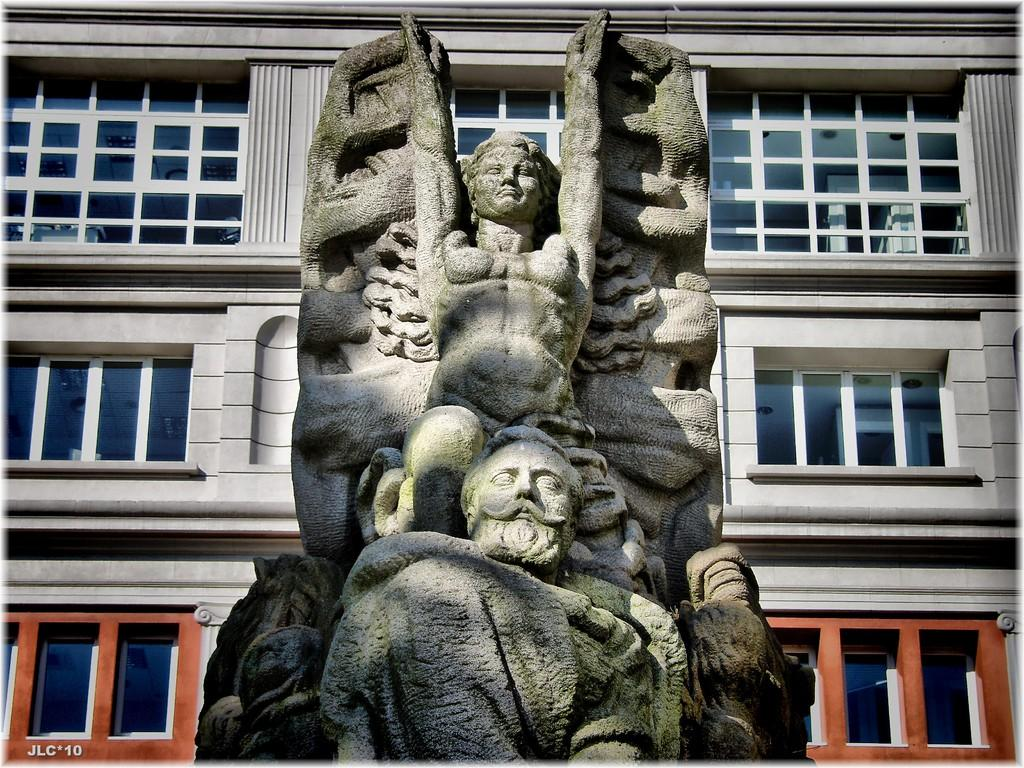What is the main subject in the image? There is a statue in the image. What can be seen in the background of the image? There is a building with windows in the background of the image. Is there any additional feature present in the image? Yes, there is a watermark in the image. What type of headwear is the statue wearing in the image? The statue does not have any headwear, as it is a statue and not a living person. Can you tell me how many wrists the statue has in the image? The statue is an inanimate object and does not have wrists, as it is not a living being. 